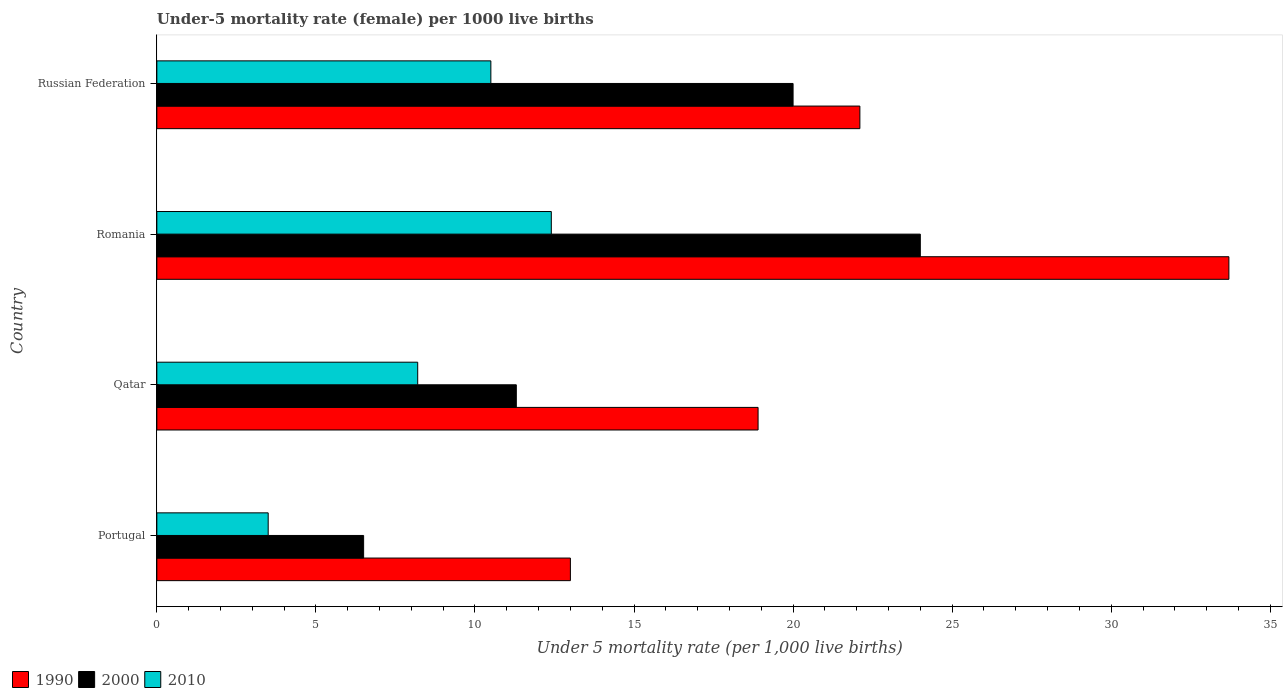Are the number of bars on each tick of the Y-axis equal?
Your response must be concise. Yes. How many bars are there on the 4th tick from the top?
Offer a very short reply. 3. How many bars are there on the 1st tick from the bottom?
Make the answer very short. 3. What is the label of the 2nd group of bars from the top?
Provide a short and direct response. Romania. In how many cases, is the number of bars for a given country not equal to the number of legend labels?
Keep it short and to the point. 0. What is the under-five mortality rate in 2010 in Portugal?
Your answer should be compact. 3.5. Across all countries, what is the maximum under-five mortality rate in 1990?
Keep it short and to the point. 33.7. Across all countries, what is the minimum under-five mortality rate in 2010?
Ensure brevity in your answer.  3.5. In which country was the under-five mortality rate in 1990 maximum?
Offer a terse response. Romania. What is the total under-five mortality rate in 2000 in the graph?
Keep it short and to the point. 61.8. What is the difference between the under-five mortality rate in 1990 in Portugal and that in Romania?
Your answer should be compact. -20.7. What is the average under-five mortality rate in 1990 per country?
Provide a short and direct response. 21.92. What is the difference between the under-five mortality rate in 2000 and under-five mortality rate in 2010 in Romania?
Provide a succinct answer. 11.6. In how many countries, is the under-five mortality rate in 2000 greater than 33 ?
Offer a very short reply. 0. What is the ratio of the under-five mortality rate in 2010 in Portugal to that in Romania?
Offer a very short reply. 0.28. Is the under-five mortality rate in 2010 in Portugal less than that in Russian Federation?
Provide a succinct answer. Yes. Is the difference between the under-five mortality rate in 2000 in Qatar and Russian Federation greater than the difference between the under-five mortality rate in 2010 in Qatar and Russian Federation?
Ensure brevity in your answer.  No. What is the difference between the highest and the second highest under-five mortality rate in 1990?
Offer a terse response. 11.6. Is the sum of the under-five mortality rate in 2000 in Portugal and Qatar greater than the maximum under-five mortality rate in 2010 across all countries?
Make the answer very short. Yes. What does the 1st bar from the top in Romania represents?
Make the answer very short. 2010. What does the 2nd bar from the bottom in Romania represents?
Offer a terse response. 2000. Is it the case that in every country, the sum of the under-five mortality rate in 2010 and under-five mortality rate in 1990 is greater than the under-five mortality rate in 2000?
Give a very brief answer. Yes. Are all the bars in the graph horizontal?
Your answer should be compact. Yes. Does the graph contain any zero values?
Offer a terse response. No. How many legend labels are there?
Offer a very short reply. 3. How are the legend labels stacked?
Offer a very short reply. Horizontal. What is the title of the graph?
Provide a short and direct response. Under-5 mortality rate (female) per 1000 live births. What is the label or title of the X-axis?
Keep it short and to the point. Under 5 mortality rate (per 1,0 live births). What is the label or title of the Y-axis?
Your answer should be compact. Country. What is the Under 5 mortality rate (per 1,000 live births) in 2000 in Portugal?
Make the answer very short. 6.5. What is the Under 5 mortality rate (per 1,000 live births) of 2010 in Portugal?
Offer a terse response. 3.5. What is the Under 5 mortality rate (per 1,000 live births) in 2010 in Qatar?
Keep it short and to the point. 8.2. What is the Under 5 mortality rate (per 1,000 live births) in 1990 in Romania?
Offer a very short reply. 33.7. What is the Under 5 mortality rate (per 1,000 live births) in 1990 in Russian Federation?
Offer a very short reply. 22.1. Across all countries, what is the maximum Under 5 mortality rate (per 1,000 live births) in 1990?
Offer a terse response. 33.7. Across all countries, what is the maximum Under 5 mortality rate (per 1,000 live births) in 2000?
Ensure brevity in your answer.  24. Across all countries, what is the minimum Under 5 mortality rate (per 1,000 live births) of 1990?
Provide a succinct answer. 13. Across all countries, what is the minimum Under 5 mortality rate (per 1,000 live births) of 2000?
Provide a short and direct response. 6.5. Across all countries, what is the minimum Under 5 mortality rate (per 1,000 live births) in 2010?
Give a very brief answer. 3.5. What is the total Under 5 mortality rate (per 1,000 live births) in 1990 in the graph?
Offer a terse response. 87.7. What is the total Under 5 mortality rate (per 1,000 live births) of 2000 in the graph?
Your answer should be compact. 61.8. What is the total Under 5 mortality rate (per 1,000 live births) of 2010 in the graph?
Keep it short and to the point. 34.6. What is the difference between the Under 5 mortality rate (per 1,000 live births) in 2000 in Portugal and that in Qatar?
Your response must be concise. -4.8. What is the difference between the Under 5 mortality rate (per 1,000 live births) of 1990 in Portugal and that in Romania?
Keep it short and to the point. -20.7. What is the difference between the Under 5 mortality rate (per 1,000 live births) of 2000 in Portugal and that in Romania?
Your response must be concise. -17.5. What is the difference between the Under 5 mortality rate (per 1,000 live births) of 2010 in Portugal and that in Romania?
Give a very brief answer. -8.9. What is the difference between the Under 5 mortality rate (per 1,000 live births) of 1990 in Portugal and that in Russian Federation?
Your answer should be very brief. -9.1. What is the difference between the Under 5 mortality rate (per 1,000 live births) of 2000 in Portugal and that in Russian Federation?
Your answer should be compact. -13.5. What is the difference between the Under 5 mortality rate (per 1,000 live births) in 2010 in Portugal and that in Russian Federation?
Keep it short and to the point. -7. What is the difference between the Under 5 mortality rate (per 1,000 live births) in 1990 in Qatar and that in Romania?
Your answer should be compact. -14.8. What is the difference between the Under 5 mortality rate (per 1,000 live births) in 2000 in Qatar and that in Romania?
Offer a terse response. -12.7. What is the difference between the Under 5 mortality rate (per 1,000 live births) of 2010 in Qatar and that in Romania?
Your response must be concise. -4.2. What is the difference between the Under 5 mortality rate (per 1,000 live births) in 1990 in Qatar and that in Russian Federation?
Your answer should be very brief. -3.2. What is the difference between the Under 5 mortality rate (per 1,000 live births) of 2000 in Qatar and that in Russian Federation?
Your answer should be compact. -8.7. What is the difference between the Under 5 mortality rate (per 1,000 live births) in 2010 in Qatar and that in Russian Federation?
Keep it short and to the point. -2.3. What is the difference between the Under 5 mortality rate (per 1,000 live births) of 1990 in Romania and that in Russian Federation?
Provide a short and direct response. 11.6. What is the difference between the Under 5 mortality rate (per 1,000 live births) in 2000 in Romania and that in Russian Federation?
Ensure brevity in your answer.  4. What is the difference between the Under 5 mortality rate (per 1,000 live births) of 2010 in Romania and that in Russian Federation?
Offer a very short reply. 1.9. What is the difference between the Under 5 mortality rate (per 1,000 live births) of 2000 in Portugal and the Under 5 mortality rate (per 1,000 live births) of 2010 in Qatar?
Keep it short and to the point. -1.7. What is the difference between the Under 5 mortality rate (per 1,000 live births) in 1990 in Portugal and the Under 5 mortality rate (per 1,000 live births) in 2010 in Romania?
Your answer should be very brief. 0.6. What is the difference between the Under 5 mortality rate (per 1,000 live births) in 2000 in Portugal and the Under 5 mortality rate (per 1,000 live births) in 2010 in Romania?
Ensure brevity in your answer.  -5.9. What is the difference between the Under 5 mortality rate (per 1,000 live births) in 1990 in Portugal and the Under 5 mortality rate (per 1,000 live births) in 2000 in Russian Federation?
Offer a terse response. -7. What is the difference between the Under 5 mortality rate (per 1,000 live births) of 1990 in Portugal and the Under 5 mortality rate (per 1,000 live births) of 2010 in Russian Federation?
Ensure brevity in your answer.  2.5. What is the difference between the Under 5 mortality rate (per 1,000 live births) of 2000 in Portugal and the Under 5 mortality rate (per 1,000 live births) of 2010 in Russian Federation?
Provide a short and direct response. -4. What is the difference between the Under 5 mortality rate (per 1,000 live births) in 1990 in Qatar and the Under 5 mortality rate (per 1,000 live births) in 2000 in Romania?
Ensure brevity in your answer.  -5.1. What is the difference between the Under 5 mortality rate (per 1,000 live births) of 1990 in Qatar and the Under 5 mortality rate (per 1,000 live births) of 2000 in Russian Federation?
Keep it short and to the point. -1.1. What is the difference between the Under 5 mortality rate (per 1,000 live births) in 2000 in Qatar and the Under 5 mortality rate (per 1,000 live births) in 2010 in Russian Federation?
Ensure brevity in your answer.  0.8. What is the difference between the Under 5 mortality rate (per 1,000 live births) of 1990 in Romania and the Under 5 mortality rate (per 1,000 live births) of 2000 in Russian Federation?
Offer a very short reply. 13.7. What is the difference between the Under 5 mortality rate (per 1,000 live births) in 1990 in Romania and the Under 5 mortality rate (per 1,000 live births) in 2010 in Russian Federation?
Give a very brief answer. 23.2. What is the average Under 5 mortality rate (per 1,000 live births) of 1990 per country?
Offer a very short reply. 21.93. What is the average Under 5 mortality rate (per 1,000 live births) of 2000 per country?
Your response must be concise. 15.45. What is the average Under 5 mortality rate (per 1,000 live births) of 2010 per country?
Offer a terse response. 8.65. What is the difference between the Under 5 mortality rate (per 1,000 live births) of 1990 and Under 5 mortality rate (per 1,000 live births) of 2000 in Portugal?
Ensure brevity in your answer.  6.5. What is the difference between the Under 5 mortality rate (per 1,000 live births) in 2000 and Under 5 mortality rate (per 1,000 live births) in 2010 in Qatar?
Keep it short and to the point. 3.1. What is the difference between the Under 5 mortality rate (per 1,000 live births) of 1990 and Under 5 mortality rate (per 1,000 live births) of 2000 in Romania?
Give a very brief answer. 9.7. What is the difference between the Under 5 mortality rate (per 1,000 live births) of 1990 and Under 5 mortality rate (per 1,000 live births) of 2010 in Romania?
Make the answer very short. 21.3. What is the difference between the Under 5 mortality rate (per 1,000 live births) in 2000 and Under 5 mortality rate (per 1,000 live births) in 2010 in Romania?
Ensure brevity in your answer.  11.6. What is the ratio of the Under 5 mortality rate (per 1,000 live births) in 1990 in Portugal to that in Qatar?
Your answer should be very brief. 0.69. What is the ratio of the Under 5 mortality rate (per 1,000 live births) of 2000 in Portugal to that in Qatar?
Keep it short and to the point. 0.58. What is the ratio of the Under 5 mortality rate (per 1,000 live births) in 2010 in Portugal to that in Qatar?
Your response must be concise. 0.43. What is the ratio of the Under 5 mortality rate (per 1,000 live births) in 1990 in Portugal to that in Romania?
Make the answer very short. 0.39. What is the ratio of the Under 5 mortality rate (per 1,000 live births) of 2000 in Portugal to that in Romania?
Offer a very short reply. 0.27. What is the ratio of the Under 5 mortality rate (per 1,000 live births) in 2010 in Portugal to that in Romania?
Your answer should be very brief. 0.28. What is the ratio of the Under 5 mortality rate (per 1,000 live births) of 1990 in Portugal to that in Russian Federation?
Your answer should be very brief. 0.59. What is the ratio of the Under 5 mortality rate (per 1,000 live births) of 2000 in Portugal to that in Russian Federation?
Your answer should be compact. 0.33. What is the ratio of the Under 5 mortality rate (per 1,000 live births) of 1990 in Qatar to that in Romania?
Give a very brief answer. 0.56. What is the ratio of the Under 5 mortality rate (per 1,000 live births) in 2000 in Qatar to that in Romania?
Offer a terse response. 0.47. What is the ratio of the Under 5 mortality rate (per 1,000 live births) of 2010 in Qatar to that in Romania?
Offer a very short reply. 0.66. What is the ratio of the Under 5 mortality rate (per 1,000 live births) of 1990 in Qatar to that in Russian Federation?
Provide a short and direct response. 0.86. What is the ratio of the Under 5 mortality rate (per 1,000 live births) of 2000 in Qatar to that in Russian Federation?
Provide a short and direct response. 0.56. What is the ratio of the Under 5 mortality rate (per 1,000 live births) in 2010 in Qatar to that in Russian Federation?
Give a very brief answer. 0.78. What is the ratio of the Under 5 mortality rate (per 1,000 live births) in 1990 in Romania to that in Russian Federation?
Your answer should be very brief. 1.52. What is the ratio of the Under 5 mortality rate (per 1,000 live births) in 2000 in Romania to that in Russian Federation?
Your answer should be very brief. 1.2. What is the ratio of the Under 5 mortality rate (per 1,000 live births) in 2010 in Romania to that in Russian Federation?
Offer a terse response. 1.18. What is the difference between the highest and the second highest Under 5 mortality rate (per 1,000 live births) of 1990?
Keep it short and to the point. 11.6. What is the difference between the highest and the second highest Under 5 mortality rate (per 1,000 live births) of 2010?
Ensure brevity in your answer.  1.9. What is the difference between the highest and the lowest Under 5 mortality rate (per 1,000 live births) in 1990?
Offer a very short reply. 20.7. What is the difference between the highest and the lowest Under 5 mortality rate (per 1,000 live births) in 2010?
Provide a succinct answer. 8.9. 